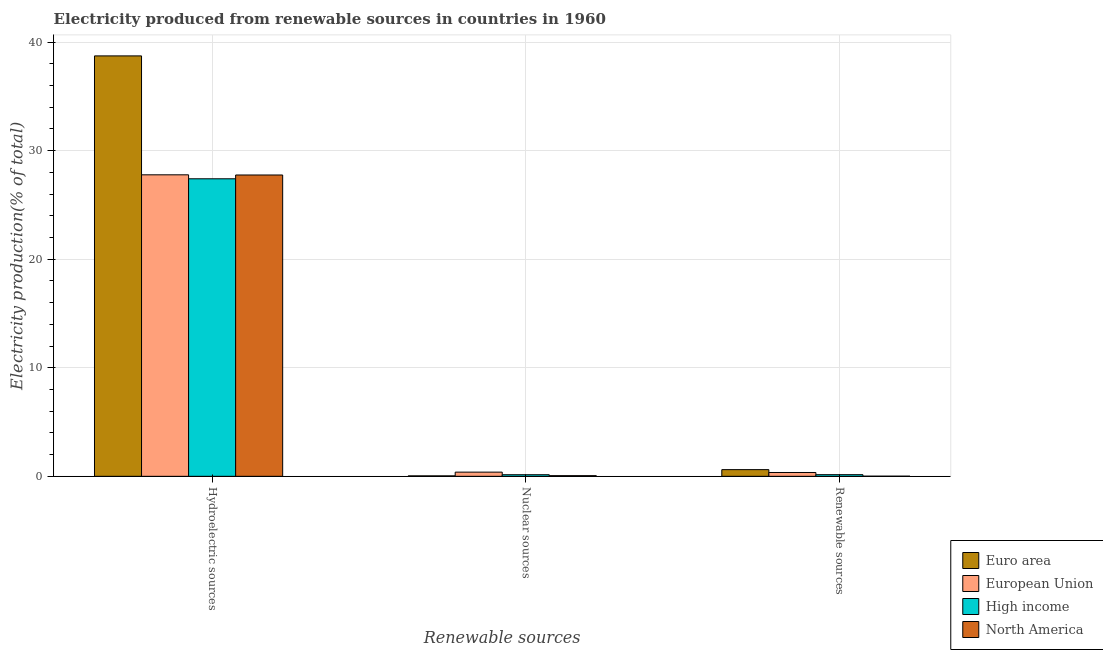How many different coloured bars are there?
Ensure brevity in your answer.  4. How many groups of bars are there?
Make the answer very short. 3. Are the number of bars on each tick of the X-axis equal?
Give a very brief answer. Yes. How many bars are there on the 3rd tick from the left?
Provide a succinct answer. 4. What is the label of the 2nd group of bars from the left?
Keep it short and to the point. Nuclear sources. What is the percentage of electricity produced by renewable sources in European Union?
Keep it short and to the point. 0.35. Across all countries, what is the maximum percentage of electricity produced by renewable sources?
Your response must be concise. 0.62. Across all countries, what is the minimum percentage of electricity produced by hydroelectric sources?
Make the answer very short. 27.41. What is the total percentage of electricity produced by nuclear sources in the graph?
Provide a succinct answer. 0.63. What is the difference between the percentage of electricity produced by nuclear sources in Euro area and that in High income?
Your response must be concise. -0.11. What is the difference between the percentage of electricity produced by renewable sources in Euro area and the percentage of electricity produced by hydroelectric sources in High income?
Provide a short and direct response. -26.79. What is the average percentage of electricity produced by hydroelectric sources per country?
Provide a short and direct response. 30.41. What is the difference between the percentage of electricity produced by nuclear sources and percentage of electricity produced by hydroelectric sources in North America?
Provide a short and direct response. -27.7. What is the ratio of the percentage of electricity produced by renewable sources in North America to that in High income?
Your answer should be compact. 0.09. What is the difference between the highest and the second highest percentage of electricity produced by nuclear sources?
Make the answer very short. 0.24. What is the difference between the highest and the lowest percentage of electricity produced by nuclear sources?
Your answer should be compact. 0.34. Is the sum of the percentage of electricity produced by renewable sources in European Union and High income greater than the maximum percentage of electricity produced by hydroelectric sources across all countries?
Your answer should be compact. No. What does the 2nd bar from the left in Nuclear sources represents?
Give a very brief answer. European Union. What does the 2nd bar from the right in Hydroelectric sources represents?
Offer a terse response. High income. Are all the bars in the graph horizontal?
Make the answer very short. No. How many countries are there in the graph?
Your answer should be very brief. 4. Are the values on the major ticks of Y-axis written in scientific E-notation?
Keep it short and to the point. No. Does the graph contain any zero values?
Offer a terse response. No. Does the graph contain grids?
Provide a succinct answer. Yes. Where does the legend appear in the graph?
Keep it short and to the point. Bottom right. How are the legend labels stacked?
Give a very brief answer. Vertical. What is the title of the graph?
Ensure brevity in your answer.  Electricity produced from renewable sources in countries in 1960. What is the label or title of the X-axis?
Keep it short and to the point. Renewable sources. What is the label or title of the Y-axis?
Keep it short and to the point. Electricity production(% of total). What is the Electricity production(% of total) in Euro area in Hydroelectric sources?
Ensure brevity in your answer.  38.73. What is the Electricity production(% of total) of European Union in Hydroelectric sources?
Make the answer very short. 27.77. What is the Electricity production(% of total) of High income in Hydroelectric sources?
Make the answer very short. 27.41. What is the Electricity production(% of total) in North America in Hydroelectric sources?
Give a very brief answer. 27.76. What is the Electricity production(% of total) of Euro area in Nuclear sources?
Your response must be concise. 0.04. What is the Electricity production(% of total) in European Union in Nuclear sources?
Give a very brief answer. 0.39. What is the Electricity production(% of total) of High income in Nuclear sources?
Make the answer very short. 0.15. What is the Electricity production(% of total) of North America in Nuclear sources?
Give a very brief answer. 0.06. What is the Electricity production(% of total) of Euro area in Renewable sources?
Give a very brief answer. 0.62. What is the Electricity production(% of total) in European Union in Renewable sources?
Your response must be concise. 0.35. What is the Electricity production(% of total) in High income in Renewable sources?
Provide a succinct answer. 0.15. What is the Electricity production(% of total) of North America in Renewable sources?
Your answer should be compact. 0.01. Across all Renewable sources, what is the maximum Electricity production(% of total) in Euro area?
Provide a short and direct response. 38.73. Across all Renewable sources, what is the maximum Electricity production(% of total) of European Union?
Provide a succinct answer. 27.77. Across all Renewable sources, what is the maximum Electricity production(% of total) of High income?
Make the answer very short. 27.41. Across all Renewable sources, what is the maximum Electricity production(% of total) in North America?
Give a very brief answer. 27.76. Across all Renewable sources, what is the minimum Electricity production(% of total) of Euro area?
Give a very brief answer. 0.04. Across all Renewable sources, what is the minimum Electricity production(% of total) in European Union?
Make the answer very short. 0.35. Across all Renewable sources, what is the minimum Electricity production(% of total) of High income?
Your answer should be very brief. 0.15. Across all Renewable sources, what is the minimum Electricity production(% of total) of North America?
Provide a short and direct response. 0.01. What is the total Electricity production(% of total) in Euro area in the graph?
Give a very brief answer. 39.38. What is the total Electricity production(% of total) of European Union in the graph?
Your response must be concise. 28.51. What is the total Electricity production(% of total) in High income in the graph?
Offer a terse response. 27.7. What is the total Electricity production(% of total) in North America in the graph?
Your response must be concise. 27.83. What is the difference between the Electricity production(% of total) in Euro area in Hydroelectric sources and that in Nuclear sources?
Keep it short and to the point. 38.68. What is the difference between the Electricity production(% of total) in European Union in Hydroelectric sources and that in Nuclear sources?
Keep it short and to the point. 27.39. What is the difference between the Electricity production(% of total) in High income in Hydroelectric sources and that in Nuclear sources?
Give a very brief answer. 27.26. What is the difference between the Electricity production(% of total) in North America in Hydroelectric sources and that in Nuclear sources?
Make the answer very short. 27.7. What is the difference between the Electricity production(% of total) in Euro area in Hydroelectric sources and that in Renewable sources?
Offer a terse response. 38.11. What is the difference between the Electricity production(% of total) of European Union in Hydroelectric sources and that in Renewable sources?
Keep it short and to the point. 27.42. What is the difference between the Electricity production(% of total) of High income in Hydroelectric sources and that in Renewable sources?
Offer a very short reply. 27.25. What is the difference between the Electricity production(% of total) in North America in Hydroelectric sources and that in Renewable sources?
Provide a short and direct response. 27.74. What is the difference between the Electricity production(% of total) of Euro area in Nuclear sources and that in Renewable sources?
Provide a succinct answer. -0.57. What is the difference between the Electricity production(% of total) of European Union in Nuclear sources and that in Renewable sources?
Your answer should be very brief. 0.03. What is the difference between the Electricity production(% of total) of High income in Nuclear sources and that in Renewable sources?
Keep it short and to the point. -0. What is the difference between the Electricity production(% of total) of North America in Nuclear sources and that in Renewable sources?
Provide a short and direct response. 0.05. What is the difference between the Electricity production(% of total) in Euro area in Hydroelectric sources and the Electricity production(% of total) in European Union in Nuclear sources?
Your answer should be very brief. 38.34. What is the difference between the Electricity production(% of total) in Euro area in Hydroelectric sources and the Electricity production(% of total) in High income in Nuclear sources?
Ensure brevity in your answer.  38.58. What is the difference between the Electricity production(% of total) in Euro area in Hydroelectric sources and the Electricity production(% of total) in North America in Nuclear sources?
Offer a very short reply. 38.66. What is the difference between the Electricity production(% of total) in European Union in Hydroelectric sources and the Electricity production(% of total) in High income in Nuclear sources?
Keep it short and to the point. 27.62. What is the difference between the Electricity production(% of total) of European Union in Hydroelectric sources and the Electricity production(% of total) of North America in Nuclear sources?
Ensure brevity in your answer.  27.71. What is the difference between the Electricity production(% of total) in High income in Hydroelectric sources and the Electricity production(% of total) in North America in Nuclear sources?
Your response must be concise. 27.34. What is the difference between the Electricity production(% of total) in Euro area in Hydroelectric sources and the Electricity production(% of total) in European Union in Renewable sources?
Your answer should be very brief. 38.37. What is the difference between the Electricity production(% of total) in Euro area in Hydroelectric sources and the Electricity production(% of total) in High income in Renewable sources?
Your answer should be very brief. 38.57. What is the difference between the Electricity production(% of total) of Euro area in Hydroelectric sources and the Electricity production(% of total) of North America in Renewable sources?
Your response must be concise. 38.71. What is the difference between the Electricity production(% of total) of European Union in Hydroelectric sources and the Electricity production(% of total) of High income in Renewable sources?
Your answer should be compact. 27.62. What is the difference between the Electricity production(% of total) of European Union in Hydroelectric sources and the Electricity production(% of total) of North America in Renewable sources?
Give a very brief answer. 27.76. What is the difference between the Electricity production(% of total) of High income in Hydroelectric sources and the Electricity production(% of total) of North America in Renewable sources?
Provide a short and direct response. 27.39. What is the difference between the Electricity production(% of total) of Euro area in Nuclear sources and the Electricity production(% of total) of European Union in Renewable sources?
Make the answer very short. -0.31. What is the difference between the Electricity production(% of total) of Euro area in Nuclear sources and the Electricity production(% of total) of High income in Renewable sources?
Offer a very short reply. -0.11. What is the difference between the Electricity production(% of total) in Euro area in Nuclear sources and the Electricity production(% of total) in North America in Renewable sources?
Offer a terse response. 0.03. What is the difference between the Electricity production(% of total) in European Union in Nuclear sources and the Electricity production(% of total) in High income in Renewable sources?
Your response must be concise. 0.24. What is the difference between the Electricity production(% of total) in European Union in Nuclear sources and the Electricity production(% of total) in North America in Renewable sources?
Make the answer very short. 0.37. What is the difference between the Electricity production(% of total) in High income in Nuclear sources and the Electricity production(% of total) in North America in Renewable sources?
Offer a very short reply. 0.13. What is the average Electricity production(% of total) of Euro area per Renewable sources?
Provide a short and direct response. 13.13. What is the average Electricity production(% of total) in European Union per Renewable sources?
Provide a short and direct response. 9.5. What is the average Electricity production(% of total) of High income per Renewable sources?
Your answer should be compact. 9.23. What is the average Electricity production(% of total) of North America per Renewable sources?
Give a very brief answer. 9.28. What is the difference between the Electricity production(% of total) in Euro area and Electricity production(% of total) in European Union in Hydroelectric sources?
Provide a succinct answer. 10.95. What is the difference between the Electricity production(% of total) of Euro area and Electricity production(% of total) of High income in Hydroelectric sources?
Ensure brevity in your answer.  11.32. What is the difference between the Electricity production(% of total) of Euro area and Electricity production(% of total) of North America in Hydroelectric sources?
Make the answer very short. 10.97. What is the difference between the Electricity production(% of total) of European Union and Electricity production(% of total) of High income in Hydroelectric sources?
Your answer should be compact. 0.37. What is the difference between the Electricity production(% of total) in European Union and Electricity production(% of total) in North America in Hydroelectric sources?
Offer a very short reply. 0.02. What is the difference between the Electricity production(% of total) in High income and Electricity production(% of total) in North America in Hydroelectric sources?
Give a very brief answer. -0.35. What is the difference between the Electricity production(% of total) in Euro area and Electricity production(% of total) in European Union in Nuclear sources?
Provide a short and direct response. -0.34. What is the difference between the Electricity production(% of total) in Euro area and Electricity production(% of total) in High income in Nuclear sources?
Provide a short and direct response. -0.11. What is the difference between the Electricity production(% of total) in Euro area and Electricity production(% of total) in North America in Nuclear sources?
Your response must be concise. -0.02. What is the difference between the Electricity production(% of total) of European Union and Electricity production(% of total) of High income in Nuclear sources?
Provide a short and direct response. 0.24. What is the difference between the Electricity production(% of total) of European Union and Electricity production(% of total) of North America in Nuclear sources?
Your response must be concise. 0.33. What is the difference between the Electricity production(% of total) of High income and Electricity production(% of total) of North America in Nuclear sources?
Keep it short and to the point. 0.09. What is the difference between the Electricity production(% of total) of Euro area and Electricity production(% of total) of European Union in Renewable sources?
Your answer should be very brief. 0.26. What is the difference between the Electricity production(% of total) in Euro area and Electricity production(% of total) in High income in Renewable sources?
Offer a very short reply. 0.46. What is the difference between the Electricity production(% of total) in Euro area and Electricity production(% of total) in North America in Renewable sources?
Keep it short and to the point. 0.6. What is the difference between the Electricity production(% of total) of European Union and Electricity production(% of total) of High income in Renewable sources?
Your answer should be very brief. 0.2. What is the difference between the Electricity production(% of total) of European Union and Electricity production(% of total) of North America in Renewable sources?
Your answer should be very brief. 0.34. What is the difference between the Electricity production(% of total) in High income and Electricity production(% of total) in North America in Renewable sources?
Your answer should be compact. 0.14. What is the ratio of the Electricity production(% of total) of Euro area in Hydroelectric sources to that in Nuclear sources?
Your answer should be very brief. 929.7. What is the ratio of the Electricity production(% of total) of European Union in Hydroelectric sources to that in Nuclear sources?
Give a very brief answer. 71.97. What is the ratio of the Electricity production(% of total) of High income in Hydroelectric sources to that in Nuclear sources?
Keep it short and to the point. 186.44. What is the ratio of the Electricity production(% of total) of North America in Hydroelectric sources to that in Nuclear sources?
Provide a succinct answer. 458.94. What is the ratio of the Electricity production(% of total) of Euro area in Hydroelectric sources to that in Renewable sources?
Give a very brief answer. 62.93. What is the ratio of the Electricity production(% of total) in European Union in Hydroelectric sources to that in Renewable sources?
Your response must be concise. 78.72. What is the ratio of the Electricity production(% of total) in High income in Hydroelectric sources to that in Renewable sources?
Offer a terse response. 181.78. What is the ratio of the Electricity production(% of total) of North America in Hydroelectric sources to that in Renewable sources?
Offer a very short reply. 2084.03. What is the ratio of the Electricity production(% of total) of Euro area in Nuclear sources to that in Renewable sources?
Your answer should be very brief. 0.07. What is the ratio of the Electricity production(% of total) in European Union in Nuclear sources to that in Renewable sources?
Keep it short and to the point. 1.09. What is the ratio of the Electricity production(% of total) in High income in Nuclear sources to that in Renewable sources?
Ensure brevity in your answer.  0.97. What is the ratio of the Electricity production(% of total) in North America in Nuclear sources to that in Renewable sources?
Make the answer very short. 4.54. What is the difference between the highest and the second highest Electricity production(% of total) of Euro area?
Keep it short and to the point. 38.11. What is the difference between the highest and the second highest Electricity production(% of total) of European Union?
Provide a succinct answer. 27.39. What is the difference between the highest and the second highest Electricity production(% of total) of High income?
Your response must be concise. 27.25. What is the difference between the highest and the second highest Electricity production(% of total) of North America?
Give a very brief answer. 27.7. What is the difference between the highest and the lowest Electricity production(% of total) of Euro area?
Provide a succinct answer. 38.68. What is the difference between the highest and the lowest Electricity production(% of total) in European Union?
Provide a succinct answer. 27.42. What is the difference between the highest and the lowest Electricity production(% of total) of High income?
Provide a succinct answer. 27.26. What is the difference between the highest and the lowest Electricity production(% of total) of North America?
Your answer should be compact. 27.74. 